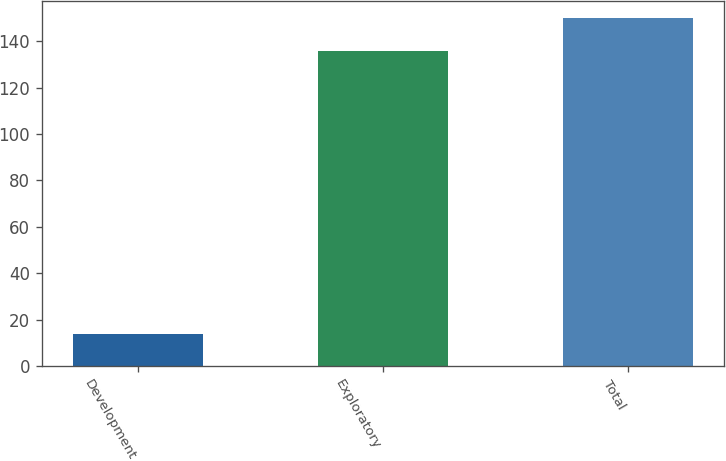Convert chart. <chart><loc_0><loc_0><loc_500><loc_500><bar_chart><fcel>Development<fcel>Exploratory<fcel>Total<nl><fcel>14<fcel>136<fcel>150<nl></chart> 